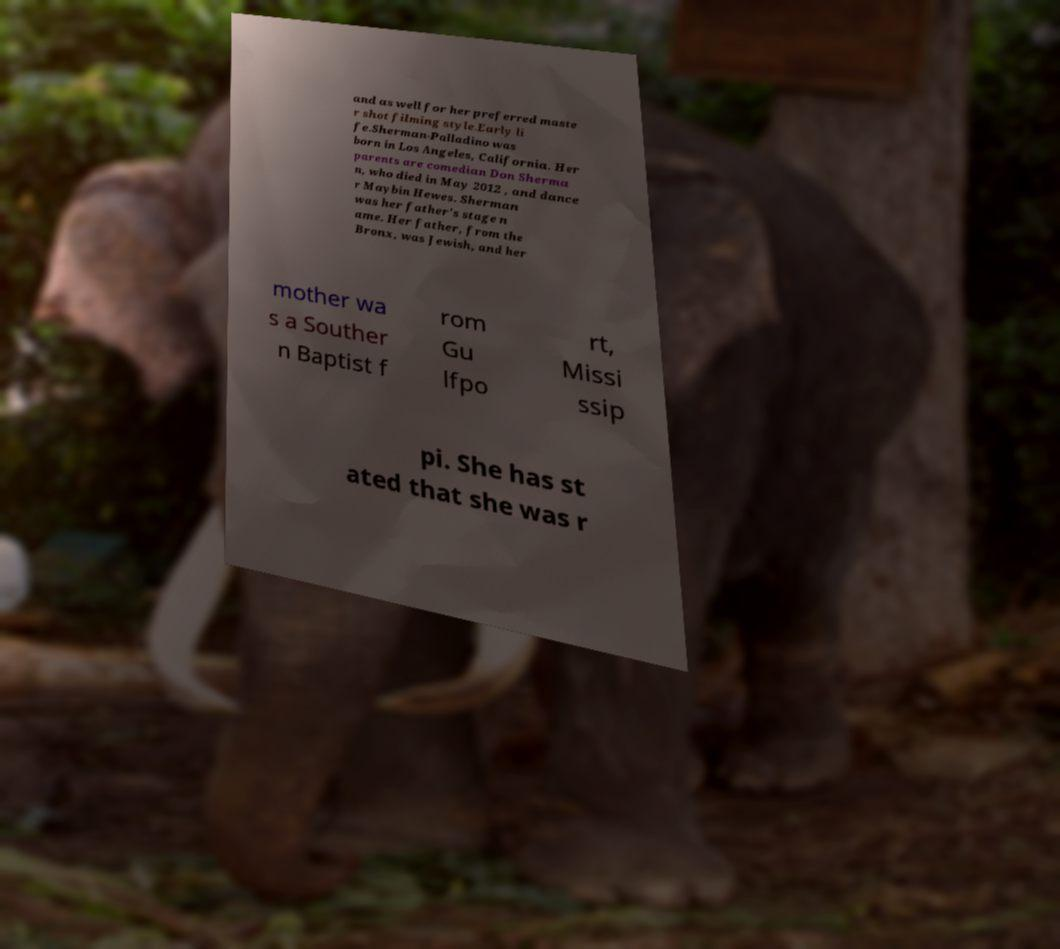Can you read and provide the text displayed in the image?This photo seems to have some interesting text. Can you extract and type it out for me? and as well for her preferred maste r shot filming style.Early li fe.Sherman-Palladino was born in Los Angeles, California. Her parents are comedian Don Sherma n, who died in May 2012 , and dance r Maybin Hewes. Sherman was her father's stage n ame. Her father, from the Bronx, was Jewish, and her mother wa s a Souther n Baptist f rom Gu lfpo rt, Missi ssip pi. She has st ated that she was r 